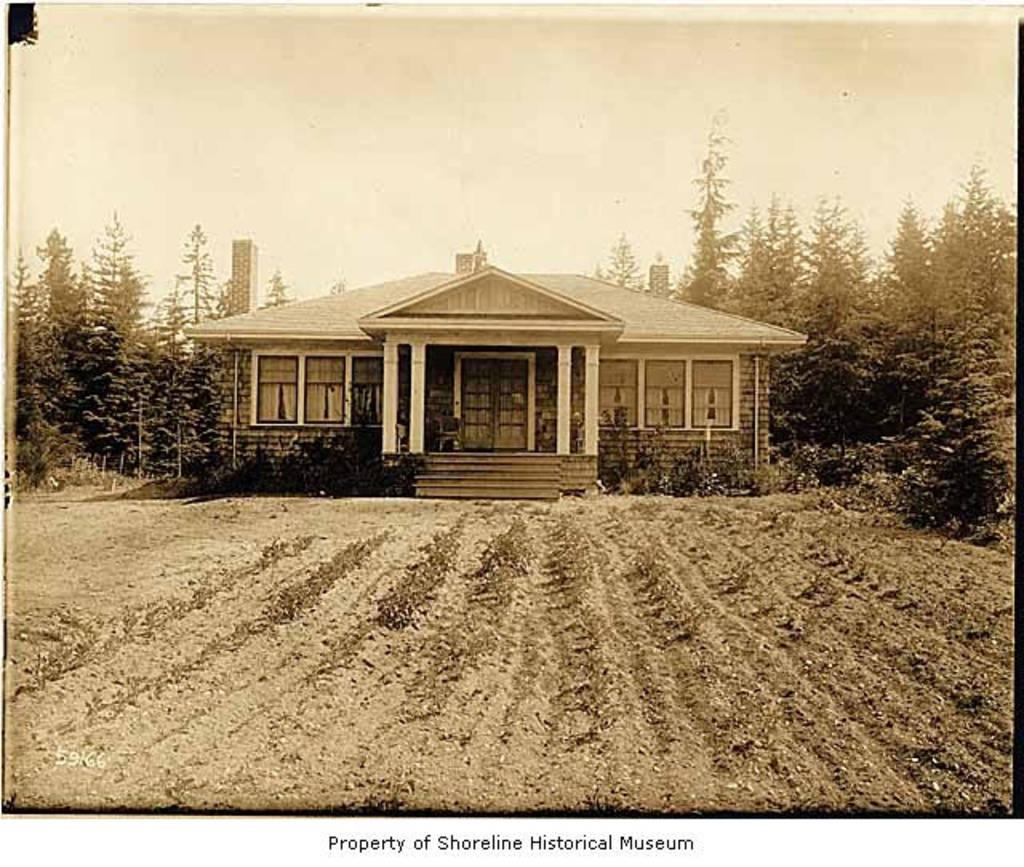What type of structure is present in the image? There is a building in the image. What other elements can be seen in the image besides the building? There are trees in the image. What is visible at the top of the image? The sky is visible at the top of the image. How many apples are hanging from the branches of the trees in the image? There are no apples visible in the image; only trees are present. Can you see any kittens playing among the trees in the image? There are no kittens present in the image; only trees and a building are visible. 